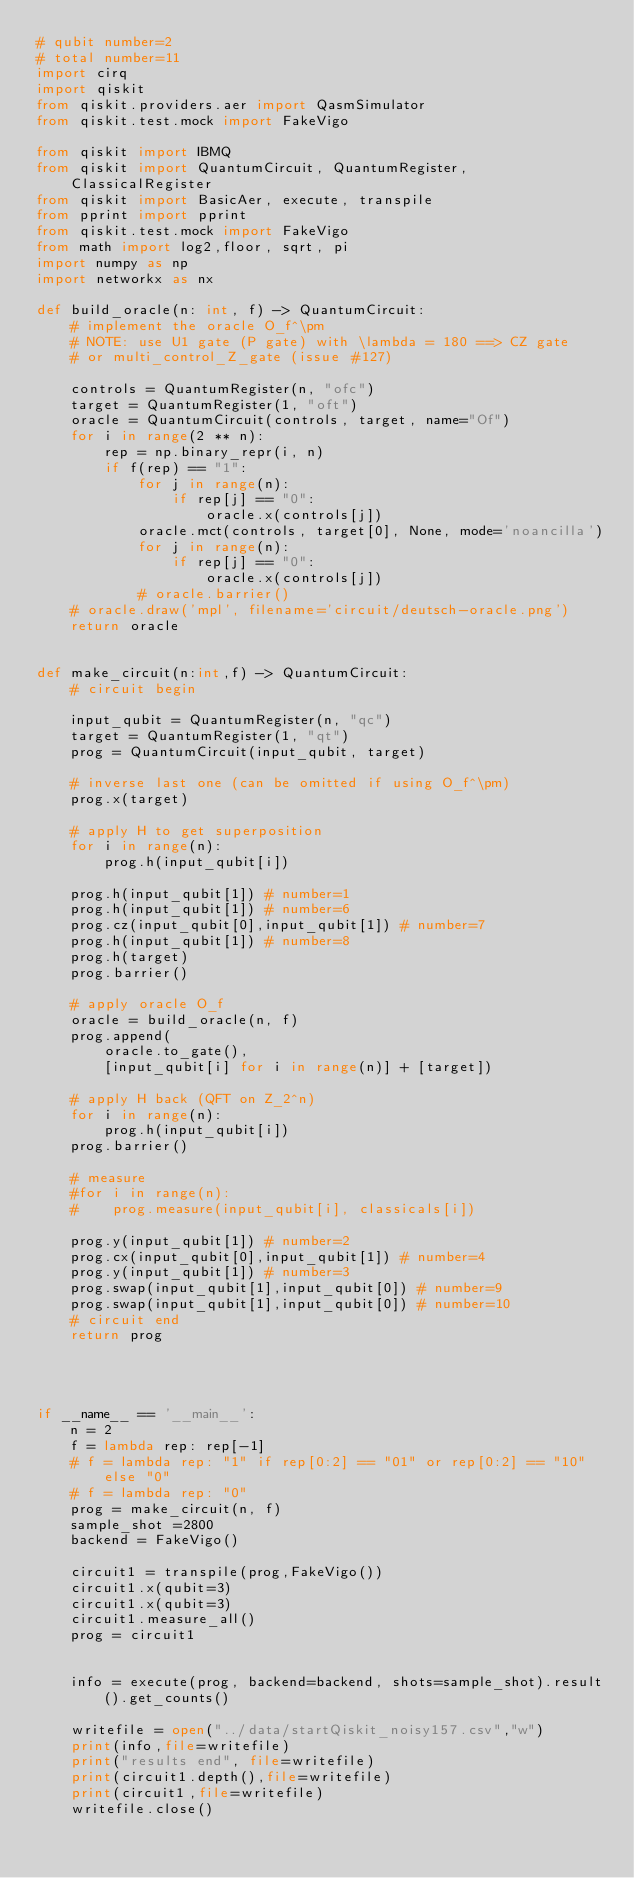Convert code to text. <code><loc_0><loc_0><loc_500><loc_500><_Python_># qubit number=2
# total number=11
import cirq
import qiskit
from qiskit.providers.aer import QasmSimulator
from qiskit.test.mock import FakeVigo

from qiskit import IBMQ
from qiskit import QuantumCircuit, QuantumRegister, ClassicalRegister
from qiskit import BasicAer, execute, transpile
from pprint import pprint
from qiskit.test.mock import FakeVigo
from math import log2,floor, sqrt, pi
import numpy as np
import networkx as nx

def build_oracle(n: int, f) -> QuantumCircuit:
    # implement the oracle O_f^\pm
    # NOTE: use U1 gate (P gate) with \lambda = 180 ==> CZ gate
    # or multi_control_Z_gate (issue #127)

    controls = QuantumRegister(n, "ofc")
    target = QuantumRegister(1, "oft")
    oracle = QuantumCircuit(controls, target, name="Of")
    for i in range(2 ** n):
        rep = np.binary_repr(i, n)
        if f(rep) == "1":
            for j in range(n):
                if rep[j] == "0":
                    oracle.x(controls[j])
            oracle.mct(controls, target[0], None, mode='noancilla')
            for j in range(n):
                if rep[j] == "0":
                    oracle.x(controls[j])
            # oracle.barrier()
    # oracle.draw('mpl', filename='circuit/deutsch-oracle.png')
    return oracle


def make_circuit(n:int,f) -> QuantumCircuit:
    # circuit begin

    input_qubit = QuantumRegister(n, "qc")
    target = QuantumRegister(1, "qt")
    prog = QuantumCircuit(input_qubit, target)

    # inverse last one (can be omitted if using O_f^\pm)
    prog.x(target)

    # apply H to get superposition
    for i in range(n):
        prog.h(input_qubit[i])

    prog.h(input_qubit[1]) # number=1
    prog.h(input_qubit[1]) # number=6
    prog.cz(input_qubit[0],input_qubit[1]) # number=7
    prog.h(input_qubit[1]) # number=8
    prog.h(target)
    prog.barrier()

    # apply oracle O_f
    oracle = build_oracle(n, f)
    prog.append(
        oracle.to_gate(),
        [input_qubit[i] for i in range(n)] + [target])

    # apply H back (QFT on Z_2^n)
    for i in range(n):
        prog.h(input_qubit[i])
    prog.barrier()

    # measure
    #for i in range(n):
    #    prog.measure(input_qubit[i], classicals[i])

    prog.y(input_qubit[1]) # number=2
    prog.cx(input_qubit[0],input_qubit[1]) # number=4
    prog.y(input_qubit[1]) # number=3
    prog.swap(input_qubit[1],input_qubit[0]) # number=9
    prog.swap(input_qubit[1],input_qubit[0]) # number=10
    # circuit end
    return prog




if __name__ == '__main__':
    n = 2
    f = lambda rep: rep[-1]
    # f = lambda rep: "1" if rep[0:2] == "01" or rep[0:2] == "10" else "0"
    # f = lambda rep: "0"
    prog = make_circuit(n, f)
    sample_shot =2800
    backend = FakeVigo()

    circuit1 = transpile(prog,FakeVigo())
    circuit1.x(qubit=3)
    circuit1.x(qubit=3)
    circuit1.measure_all()
    prog = circuit1


    info = execute(prog, backend=backend, shots=sample_shot).result().get_counts()

    writefile = open("../data/startQiskit_noisy157.csv","w")
    print(info,file=writefile)
    print("results end", file=writefile)
    print(circuit1.depth(),file=writefile)
    print(circuit1,file=writefile)
    writefile.close()
</code> 